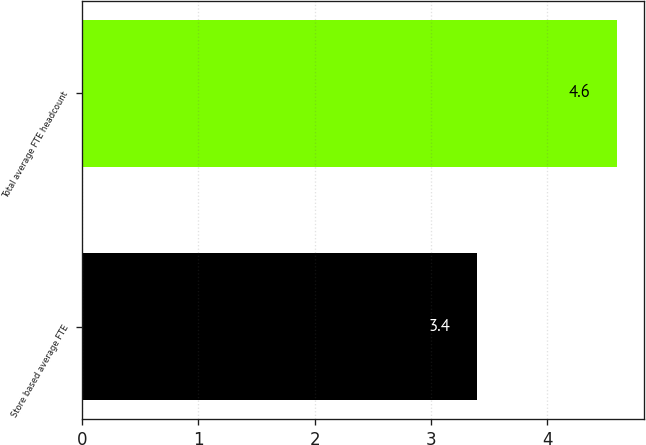Convert chart. <chart><loc_0><loc_0><loc_500><loc_500><bar_chart><fcel>Store based average FTE<fcel>Total average FTE headcount<nl><fcel>3.4<fcel>4.6<nl></chart> 